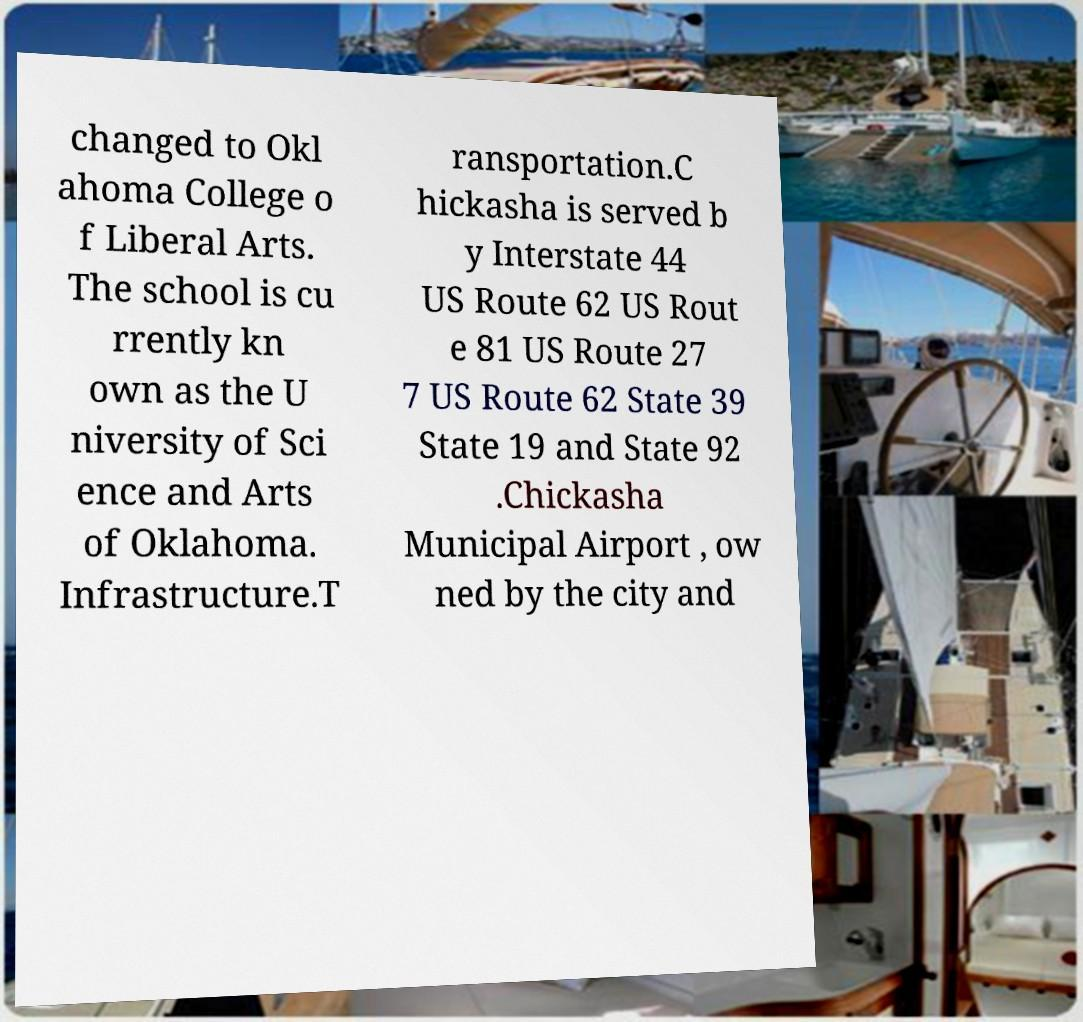Please identify and transcribe the text found in this image. changed to Okl ahoma College o f Liberal Arts. The school is cu rrently kn own as the U niversity of Sci ence and Arts of Oklahoma. Infrastructure.T ransportation.C hickasha is served b y Interstate 44 US Route 62 US Rout e 81 US Route 27 7 US Route 62 State 39 State 19 and State 92 .Chickasha Municipal Airport , ow ned by the city and 